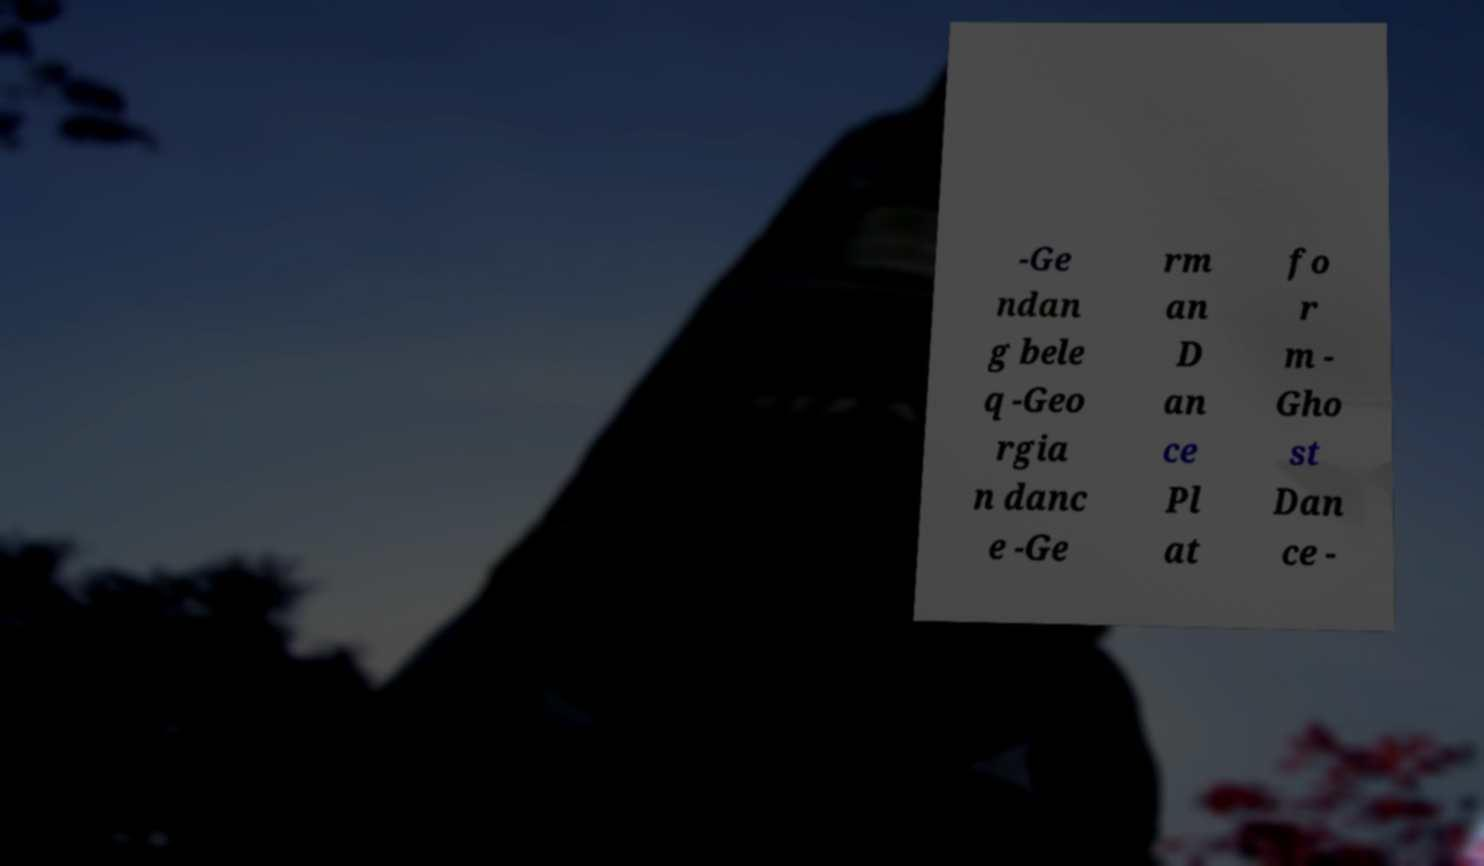For documentation purposes, I need the text within this image transcribed. Could you provide that? -Ge ndan g bele q -Geo rgia n danc e -Ge rm an D an ce Pl at fo r m - Gho st Dan ce - 